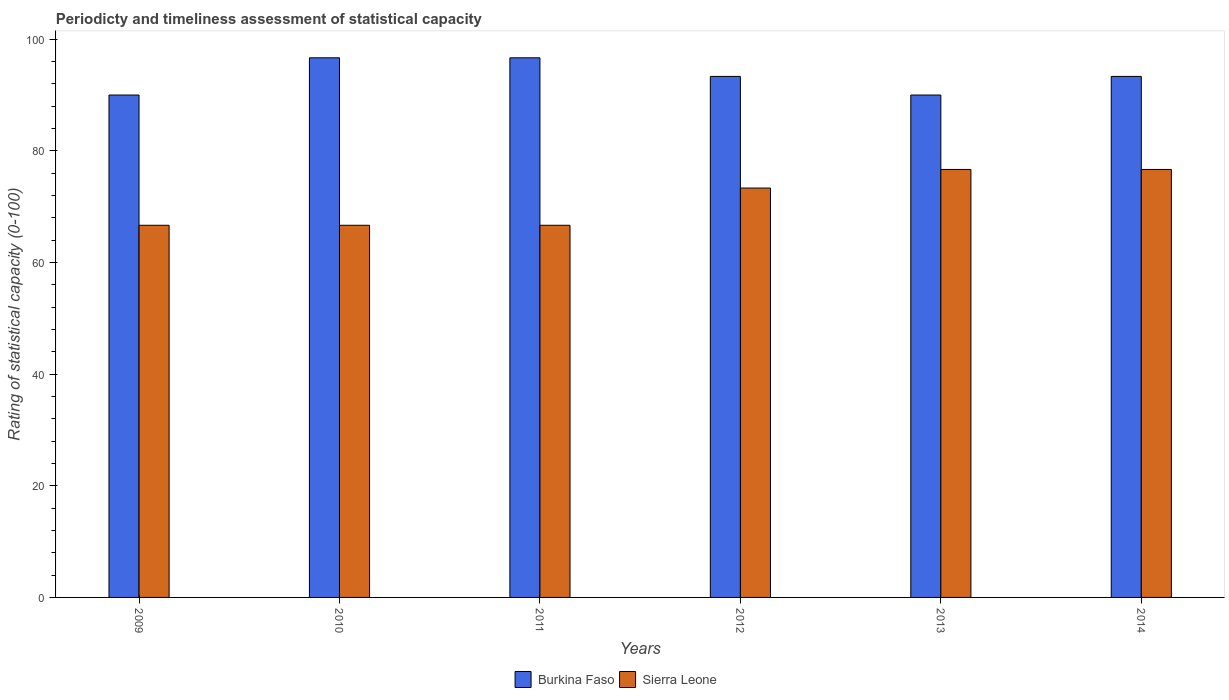Are the number of bars per tick equal to the number of legend labels?
Provide a short and direct response. Yes. Are the number of bars on each tick of the X-axis equal?
Offer a terse response. Yes. How many bars are there on the 5th tick from the left?
Your response must be concise. 2. What is the label of the 6th group of bars from the left?
Ensure brevity in your answer.  2014. In how many cases, is the number of bars for a given year not equal to the number of legend labels?
Offer a very short reply. 0. What is the rating of statistical capacity in Sierra Leone in 2011?
Make the answer very short. 66.67. Across all years, what is the maximum rating of statistical capacity in Sierra Leone?
Provide a succinct answer. 76.67. Across all years, what is the minimum rating of statistical capacity in Sierra Leone?
Provide a short and direct response. 66.67. In which year was the rating of statistical capacity in Burkina Faso maximum?
Provide a succinct answer. 2010. In which year was the rating of statistical capacity in Burkina Faso minimum?
Offer a terse response. 2009. What is the total rating of statistical capacity in Burkina Faso in the graph?
Make the answer very short. 560. What is the difference between the rating of statistical capacity in Burkina Faso in 2010 and that in 2013?
Ensure brevity in your answer.  6.67. What is the difference between the rating of statistical capacity in Sierra Leone in 2012 and the rating of statistical capacity in Burkina Faso in 2013?
Provide a short and direct response. -16.67. What is the average rating of statistical capacity in Sierra Leone per year?
Make the answer very short. 71.11. In the year 2013, what is the difference between the rating of statistical capacity in Burkina Faso and rating of statistical capacity in Sierra Leone?
Give a very brief answer. 13.33. In how many years, is the rating of statistical capacity in Burkina Faso greater than 24?
Your answer should be very brief. 6. What is the difference between the highest and the lowest rating of statistical capacity in Sierra Leone?
Your answer should be very brief. 10. In how many years, is the rating of statistical capacity in Burkina Faso greater than the average rating of statistical capacity in Burkina Faso taken over all years?
Provide a short and direct response. 2. Is the sum of the rating of statistical capacity in Sierra Leone in 2009 and 2011 greater than the maximum rating of statistical capacity in Burkina Faso across all years?
Offer a terse response. Yes. What does the 1st bar from the left in 2011 represents?
Ensure brevity in your answer.  Burkina Faso. What does the 1st bar from the right in 2011 represents?
Offer a terse response. Sierra Leone. What is the difference between two consecutive major ticks on the Y-axis?
Your response must be concise. 20. Are the values on the major ticks of Y-axis written in scientific E-notation?
Make the answer very short. No. Does the graph contain grids?
Your response must be concise. No. How many legend labels are there?
Your answer should be very brief. 2. What is the title of the graph?
Offer a very short reply. Periodicty and timeliness assessment of statistical capacity. What is the label or title of the Y-axis?
Give a very brief answer. Rating of statistical capacity (0-100). What is the Rating of statistical capacity (0-100) in Sierra Leone in 2009?
Provide a short and direct response. 66.67. What is the Rating of statistical capacity (0-100) of Burkina Faso in 2010?
Offer a terse response. 96.67. What is the Rating of statistical capacity (0-100) in Sierra Leone in 2010?
Your answer should be compact. 66.67. What is the Rating of statistical capacity (0-100) in Burkina Faso in 2011?
Offer a terse response. 96.67. What is the Rating of statistical capacity (0-100) of Sierra Leone in 2011?
Give a very brief answer. 66.67. What is the Rating of statistical capacity (0-100) in Burkina Faso in 2012?
Your answer should be compact. 93.33. What is the Rating of statistical capacity (0-100) in Sierra Leone in 2012?
Give a very brief answer. 73.33. What is the Rating of statistical capacity (0-100) of Burkina Faso in 2013?
Your response must be concise. 90. What is the Rating of statistical capacity (0-100) of Sierra Leone in 2013?
Keep it short and to the point. 76.67. What is the Rating of statistical capacity (0-100) in Burkina Faso in 2014?
Ensure brevity in your answer.  93.33. What is the Rating of statistical capacity (0-100) of Sierra Leone in 2014?
Your answer should be very brief. 76.67. Across all years, what is the maximum Rating of statistical capacity (0-100) in Burkina Faso?
Provide a succinct answer. 96.67. Across all years, what is the maximum Rating of statistical capacity (0-100) in Sierra Leone?
Offer a terse response. 76.67. Across all years, what is the minimum Rating of statistical capacity (0-100) in Burkina Faso?
Keep it short and to the point. 90. Across all years, what is the minimum Rating of statistical capacity (0-100) in Sierra Leone?
Your answer should be very brief. 66.67. What is the total Rating of statistical capacity (0-100) in Burkina Faso in the graph?
Your response must be concise. 560. What is the total Rating of statistical capacity (0-100) of Sierra Leone in the graph?
Give a very brief answer. 426.67. What is the difference between the Rating of statistical capacity (0-100) in Burkina Faso in 2009 and that in 2010?
Ensure brevity in your answer.  -6.67. What is the difference between the Rating of statistical capacity (0-100) of Sierra Leone in 2009 and that in 2010?
Offer a terse response. 0. What is the difference between the Rating of statistical capacity (0-100) in Burkina Faso in 2009 and that in 2011?
Your answer should be very brief. -6.67. What is the difference between the Rating of statistical capacity (0-100) in Burkina Faso in 2009 and that in 2012?
Ensure brevity in your answer.  -3.33. What is the difference between the Rating of statistical capacity (0-100) of Sierra Leone in 2009 and that in 2012?
Ensure brevity in your answer.  -6.67. What is the difference between the Rating of statistical capacity (0-100) in Burkina Faso in 2009 and that in 2013?
Provide a short and direct response. 0. What is the difference between the Rating of statistical capacity (0-100) in Burkina Faso in 2009 and that in 2014?
Your response must be concise. -3.33. What is the difference between the Rating of statistical capacity (0-100) of Burkina Faso in 2010 and that in 2012?
Give a very brief answer. 3.33. What is the difference between the Rating of statistical capacity (0-100) in Sierra Leone in 2010 and that in 2012?
Offer a terse response. -6.67. What is the difference between the Rating of statistical capacity (0-100) of Sierra Leone in 2011 and that in 2012?
Your response must be concise. -6.67. What is the difference between the Rating of statistical capacity (0-100) in Burkina Faso in 2011 and that in 2013?
Offer a terse response. 6.67. What is the difference between the Rating of statistical capacity (0-100) in Burkina Faso in 2011 and that in 2014?
Your answer should be compact. 3.33. What is the difference between the Rating of statistical capacity (0-100) in Sierra Leone in 2011 and that in 2014?
Ensure brevity in your answer.  -10. What is the difference between the Rating of statistical capacity (0-100) of Burkina Faso in 2012 and that in 2013?
Provide a succinct answer. 3.33. What is the difference between the Rating of statistical capacity (0-100) of Sierra Leone in 2012 and that in 2013?
Provide a succinct answer. -3.33. What is the difference between the Rating of statistical capacity (0-100) in Burkina Faso in 2012 and that in 2014?
Offer a very short reply. -0. What is the difference between the Rating of statistical capacity (0-100) in Burkina Faso in 2013 and that in 2014?
Your answer should be very brief. -3.33. What is the difference between the Rating of statistical capacity (0-100) in Sierra Leone in 2013 and that in 2014?
Your answer should be compact. 0. What is the difference between the Rating of statistical capacity (0-100) in Burkina Faso in 2009 and the Rating of statistical capacity (0-100) in Sierra Leone in 2010?
Your response must be concise. 23.33. What is the difference between the Rating of statistical capacity (0-100) of Burkina Faso in 2009 and the Rating of statistical capacity (0-100) of Sierra Leone in 2011?
Offer a very short reply. 23.33. What is the difference between the Rating of statistical capacity (0-100) of Burkina Faso in 2009 and the Rating of statistical capacity (0-100) of Sierra Leone in 2012?
Your answer should be very brief. 16.67. What is the difference between the Rating of statistical capacity (0-100) of Burkina Faso in 2009 and the Rating of statistical capacity (0-100) of Sierra Leone in 2013?
Your answer should be very brief. 13.33. What is the difference between the Rating of statistical capacity (0-100) in Burkina Faso in 2009 and the Rating of statistical capacity (0-100) in Sierra Leone in 2014?
Provide a short and direct response. 13.33. What is the difference between the Rating of statistical capacity (0-100) of Burkina Faso in 2010 and the Rating of statistical capacity (0-100) of Sierra Leone in 2012?
Provide a succinct answer. 23.33. What is the difference between the Rating of statistical capacity (0-100) in Burkina Faso in 2011 and the Rating of statistical capacity (0-100) in Sierra Leone in 2012?
Ensure brevity in your answer.  23.33. What is the difference between the Rating of statistical capacity (0-100) of Burkina Faso in 2011 and the Rating of statistical capacity (0-100) of Sierra Leone in 2013?
Give a very brief answer. 20. What is the difference between the Rating of statistical capacity (0-100) of Burkina Faso in 2012 and the Rating of statistical capacity (0-100) of Sierra Leone in 2013?
Give a very brief answer. 16.67. What is the difference between the Rating of statistical capacity (0-100) of Burkina Faso in 2012 and the Rating of statistical capacity (0-100) of Sierra Leone in 2014?
Your answer should be very brief. 16.67. What is the difference between the Rating of statistical capacity (0-100) of Burkina Faso in 2013 and the Rating of statistical capacity (0-100) of Sierra Leone in 2014?
Ensure brevity in your answer.  13.33. What is the average Rating of statistical capacity (0-100) of Burkina Faso per year?
Your answer should be compact. 93.33. What is the average Rating of statistical capacity (0-100) in Sierra Leone per year?
Your answer should be compact. 71.11. In the year 2009, what is the difference between the Rating of statistical capacity (0-100) of Burkina Faso and Rating of statistical capacity (0-100) of Sierra Leone?
Offer a very short reply. 23.33. In the year 2010, what is the difference between the Rating of statistical capacity (0-100) of Burkina Faso and Rating of statistical capacity (0-100) of Sierra Leone?
Make the answer very short. 30. In the year 2011, what is the difference between the Rating of statistical capacity (0-100) of Burkina Faso and Rating of statistical capacity (0-100) of Sierra Leone?
Ensure brevity in your answer.  30. In the year 2012, what is the difference between the Rating of statistical capacity (0-100) in Burkina Faso and Rating of statistical capacity (0-100) in Sierra Leone?
Offer a terse response. 20. In the year 2013, what is the difference between the Rating of statistical capacity (0-100) of Burkina Faso and Rating of statistical capacity (0-100) of Sierra Leone?
Provide a succinct answer. 13.33. In the year 2014, what is the difference between the Rating of statistical capacity (0-100) in Burkina Faso and Rating of statistical capacity (0-100) in Sierra Leone?
Keep it short and to the point. 16.67. What is the ratio of the Rating of statistical capacity (0-100) in Sierra Leone in 2009 to that in 2010?
Give a very brief answer. 1. What is the ratio of the Rating of statistical capacity (0-100) of Sierra Leone in 2009 to that in 2012?
Offer a very short reply. 0.91. What is the ratio of the Rating of statistical capacity (0-100) in Sierra Leone in 2009 to that in 2013?
Your response must be concise. 0.87. What is the ratio of the Rating of statistical capacity (0-100) of Burkina Faso in 2009 to that in 2014?
Your response must be concise. 0.96. What is the ratio of the Rating of statistical capacity (0-100) of Sierra Leone in 2009 to that in 2014?
Provide a short and direct response. 0.87. What is the ratio of the Rating of statistical capacity (0-100) in Burkina Faso in 2010 to that in 2012?
Provide a succinct answer. 1.04. What is the ratio of the Rating of statistical capacity (0-100) of Sierra Leone in 2010 to that in 2012?
Keep it short and to the point. 0.91. What is the ratio of the Rating of statistical capacity (0-100) in Burkina Faso in 2010 to that in 2013?
Make the answer very short. 1.07. What is the ratio of the Rating of statistical capacity (0-100) in Sierra Leone in 2010 to that in 2013?
Provide a short and direct response. 0.87. What is the ratio of the Rating of statistical capacity (0-100) of Burkina Faso in 2010 to that in 2014?
Make the answer very short. 1.04. What is the ratio of the Rating of statistical capacity (0-100) in Sierra Leone in 2010 to that in 2014?
Offer a terse response. 0.87. What is the ratio of the Rating of statistical capacity (0-100) in Burkina Faso in 2011 to that in 2012?
Your response must be concise. 1.04. What is the ratio of the Rating of statistical capacity (0-100) of Burkina Faso in 2011 to that in 2013?
Provide a succinct answer. 1.07. What is the ratio of the Rating of statistical capacity (0-100) in Sierra Leone in 2011 to that in 2013?
Offer a terse response. 0.87. What is the ratio of the Rating of statistical capacity (0-100) of Burkina Faso in 2011 to that in 2014?
Your response must be concise. 1.04. What is the ratio of the Rating of statistical capacity (0-100) in Sierra Leone in 2011 to that in 2014?
Ensure brevity in your answer.  0.87. What is the ratio of the Rating of statistical capacity (0-100) of Sierra Leone in 2012 to that in 2013?
Give a very brief answer. 0.96. What is the ratio of the Rating of statistical capacity (0-100) in Burkina Faso in 2012 to that in 2014?
Ensure brevity in your answer.  1. What is the ratio of the Rating of statistical capacity (0-100) in Sierra Leone in 2012 to that in 2014?
Provide a succinct answer. 0.96. What is the ratio of the Rating of statistical capacity (0-100) of Burkina Faso in 2013 to that in 2014?
Provide a short and direct response. 0.96. What is the ratio of the Rating of statistical capacity (0-100) in Sierra Leone in 2013 to that in 2014?
Keep it short and to the point. 1. What is the difference between the highest and the lowest Rating of statistical capacity (0-100) in Burkina Faso?
Make the answer very short. 6.67. What is the difference between the highest and the lowest Rating of statistical capacity (0-100) in Sierra Leone?
Your answer should be compact. 10. 